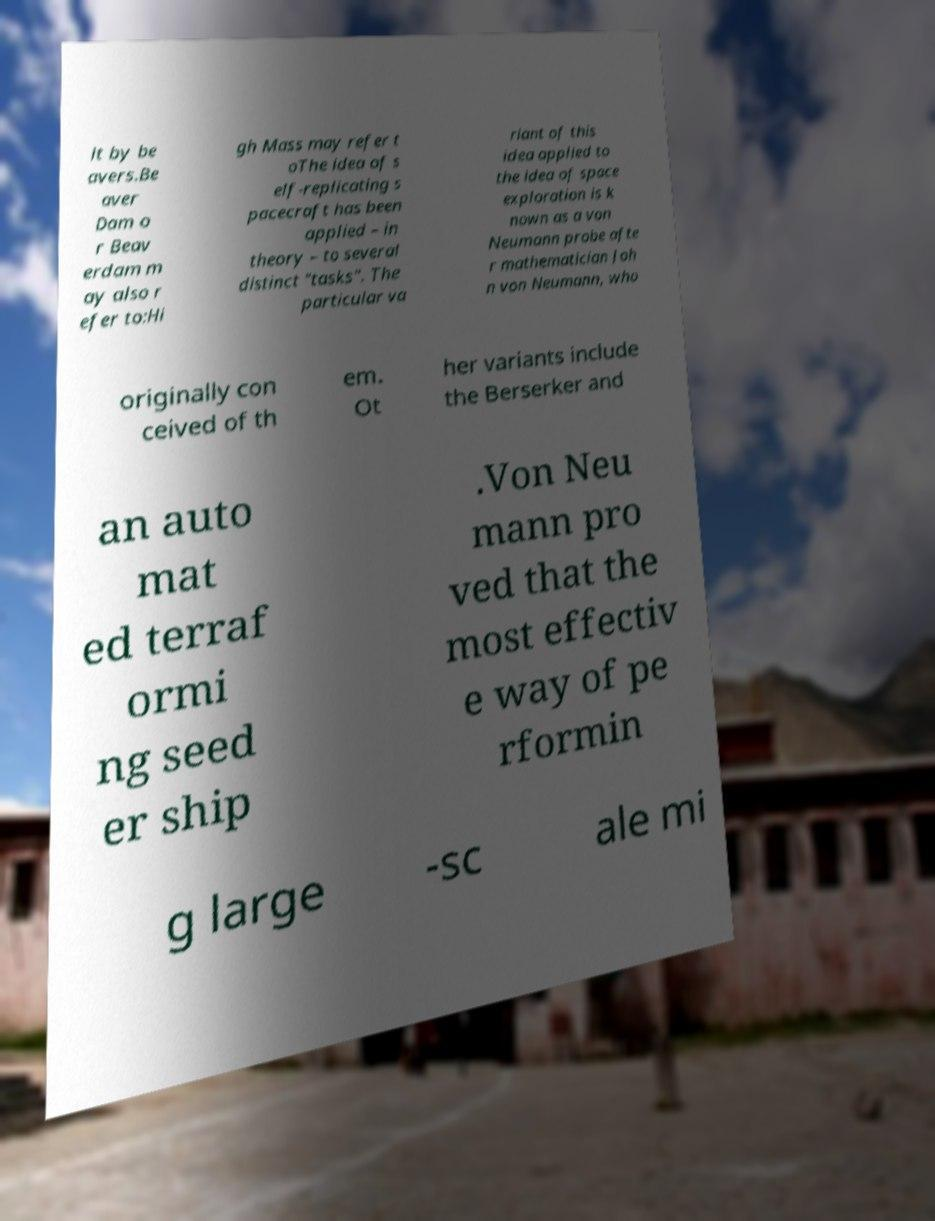Could you extract and type out the text from this image? lt by be avers.Be aver Dam o r Beav erdam m ay also r efer to:Hi gh Mass may refer t oThe idea of s elf-replicating s pacecraft has been applied – in theory – to several distinct "tasks". The particular va riant of this idea applied to the idea of space exploration is k nown as a von Neumann probe afte r mathematician Joh n von Neumann, who originally con ceived of th em. Ot her variants include the Berserker and an auto mat ed terraf ormi ng seed er ship .Von Neu mann pro ved that the most effectiv e way of pe rformin g large -sc ale mi 